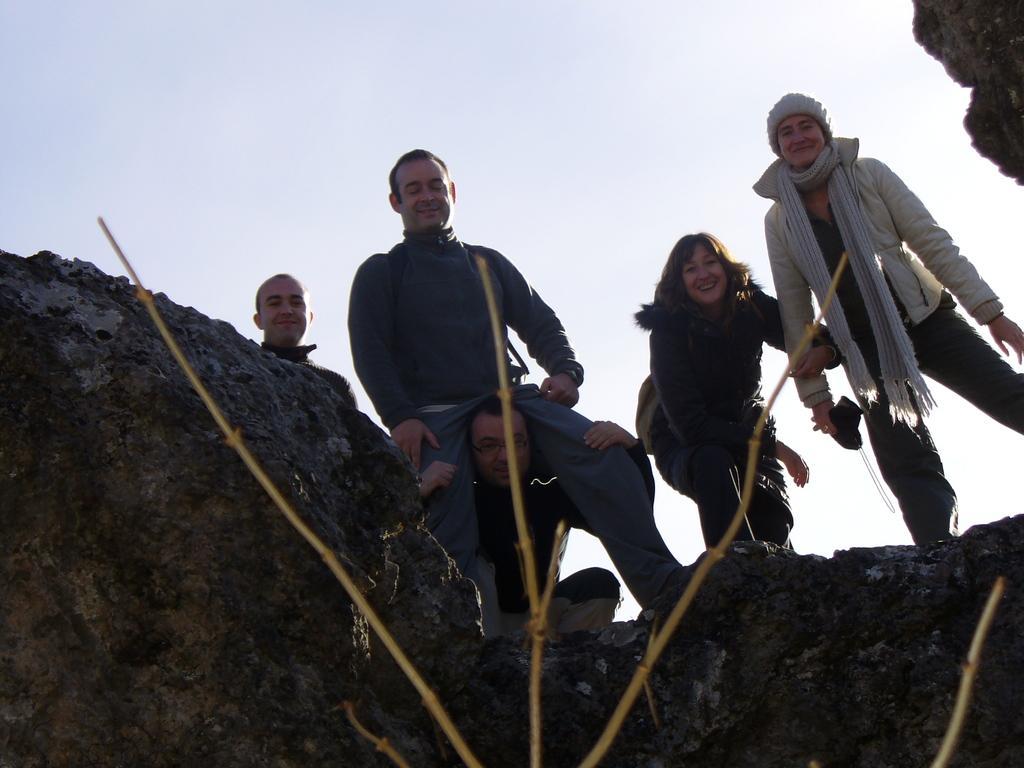Could you give a brief overview of what you see in this image? In the picture I can see rocks, a person carrying another person, two women standing on the right side of the image and another person standing on the left side of the image. In the background, I can see the plain sky. 